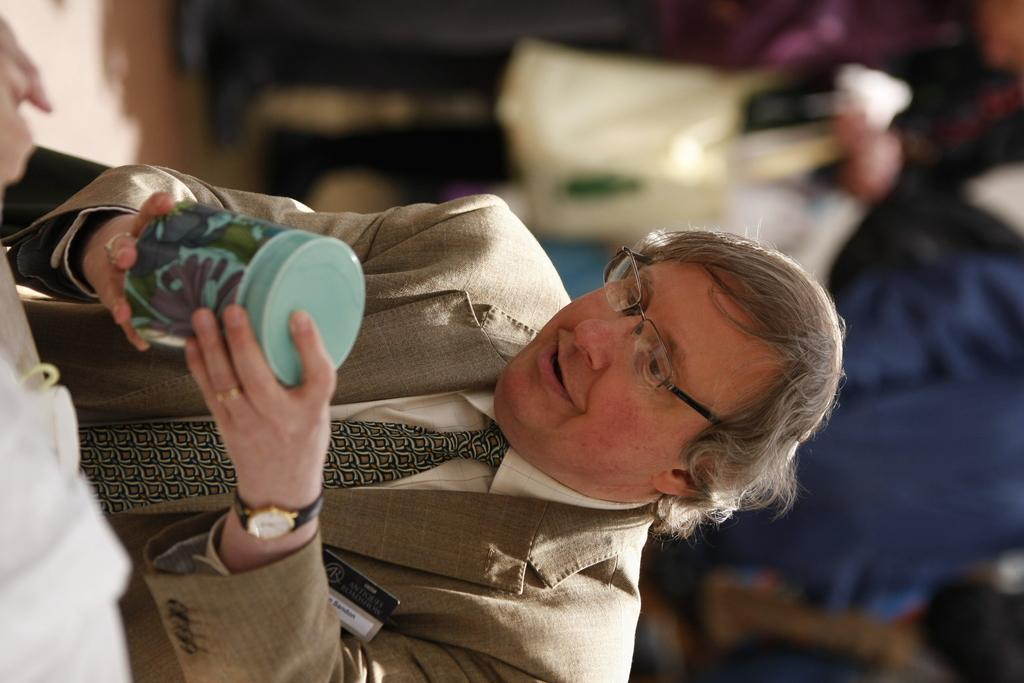Who is present in the image? There is a man in the image. What is the man holding in the image? The man is holding a box. Can you describe the background of the image? The background of the image is blurred. What type of straw is the man using to measure the unit in the image? There is no straw or unit present in the image; the man is simply holding a box. 